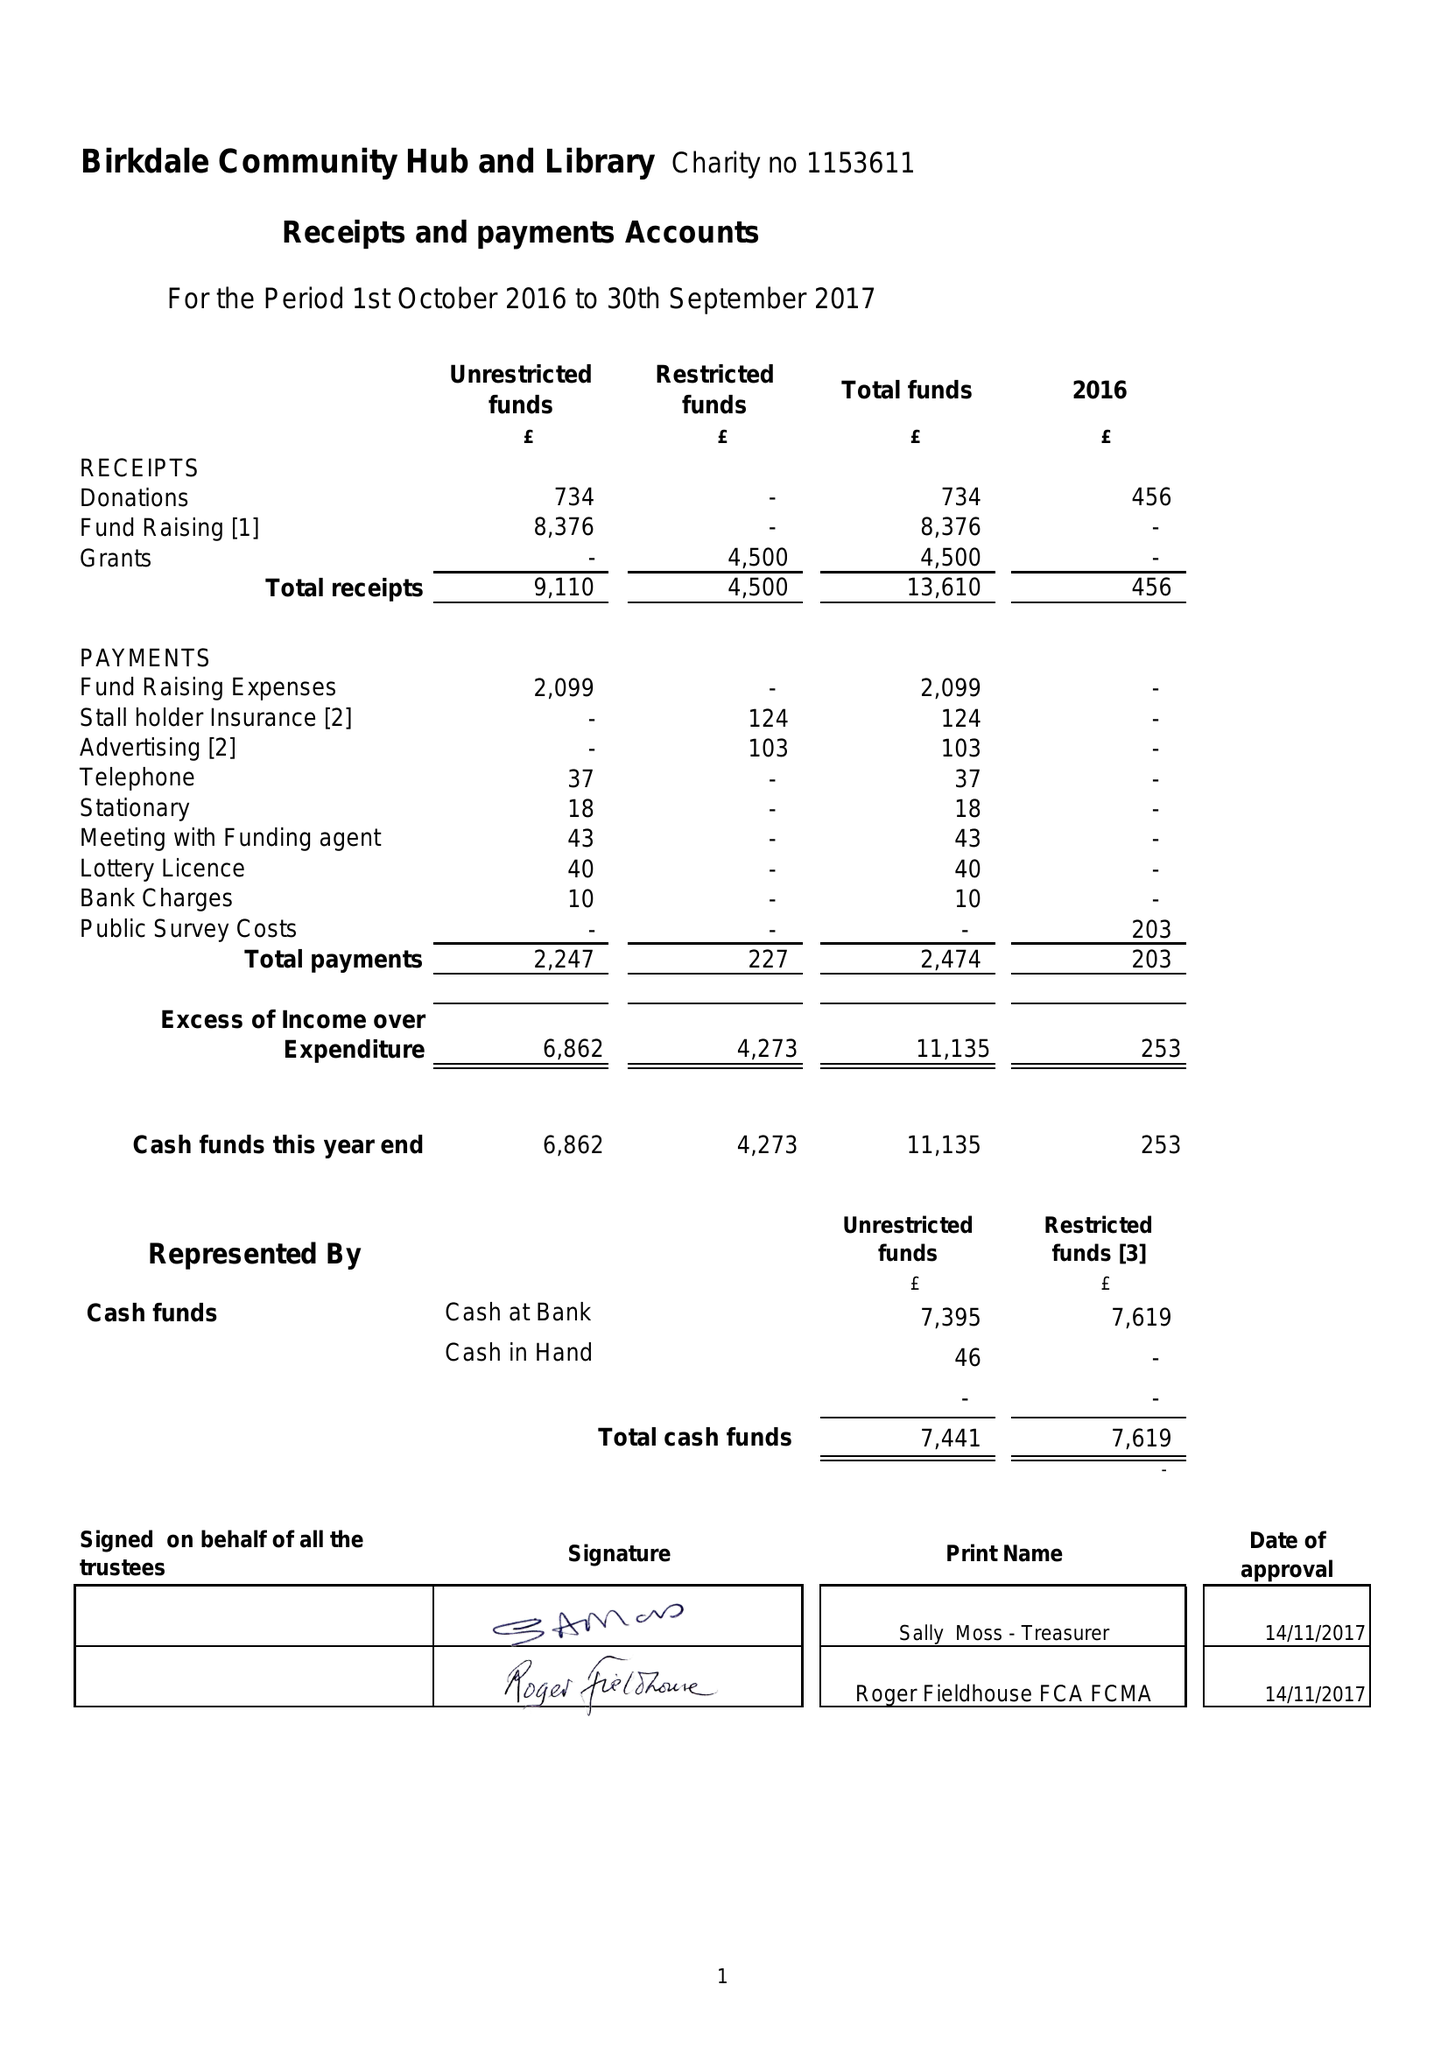What is the value for the income_annually_in_british_pounds?
Answer the question using a single word or phrase. 13610.00 